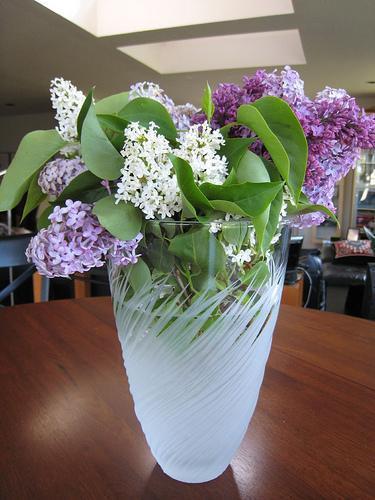How many vases are on the table?
Give a very brief answer. 1. How many chairs are there?
Give a very brief answer. 1. 